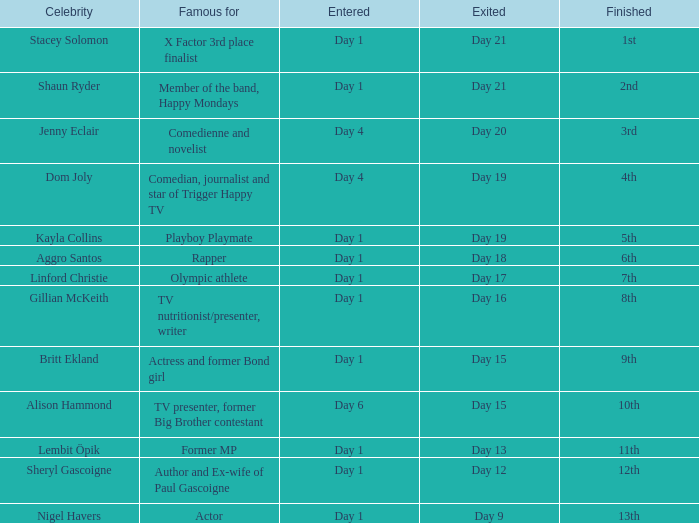Who is a celebrity known primarily for their acting career? Nigel Havers. 